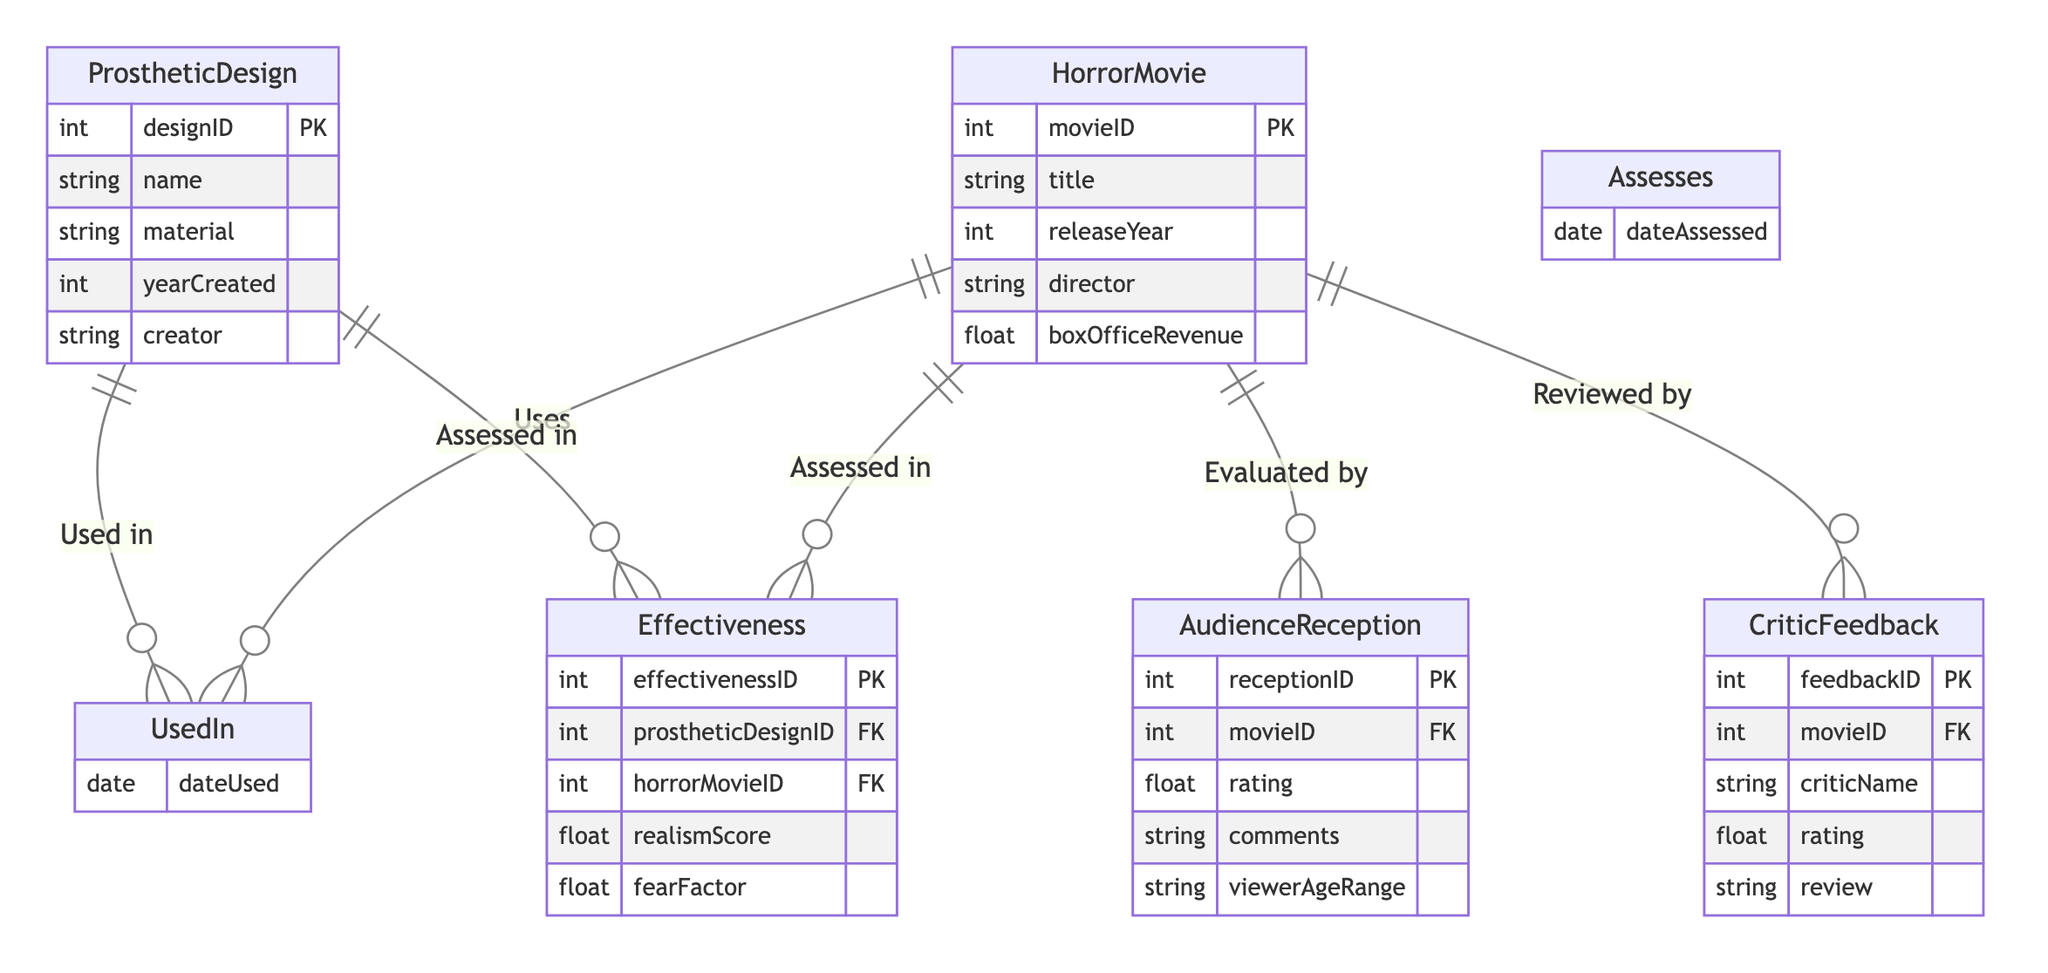What is the primary entity in the diagram? The diagram presents various entities, but the primary entity, reflecting the central theme of evaluating prosthetic designs in horror films, is "HorrorMovie."
Answer: HorrorMovie How many entities are represented in the diagram? The diagram contains a total of five distinct entities: ProstheticDesign, HorrorMovie, AudienceReception, CriticFeedback, and Effectiveness.
Answer: Five What relationship exists between ProstheticDesign and HorrorMovie? There is a relationship labeled "UsedIn," which indicates that a prosthetic design can be used in a horror movie, contributing to its visual effects.
Answer: UsedIn What attribute is present in CriticFeedback but not in AudienceReception? The CriticFeedback entity includes the attribute "criticName," which is not found in the AudienceReception entity.
Answer: criticName How is the Effectiveness of a prosthetic design assessed? The effectiveness is assessed based on two entities: "ProstheticDesign" and "HorrorMovie", in addition to the effectivenessScore and fearFactor attributes, which evaluate the realism of the design within the movie context.
Answer: Assessed in Which entity has a "rating" attribute? The entities "AudienceReception" and "CriticFeedback" both feature the "rating" attribute, indicating audience and critic evaluations respectively.
Answer: AudienceReception, CriticFeedback What is a unique attribute of the ProstheticDesign entity? The "ProstheticDesign" entity uniquely includes the attribute "yearCreated," which specifies when the design was made.
Answer: yearCreated Which entity allows for comments from viewers? The "AudienceReception" entity is designed to capture viewer feedback, which includes comments along with ratings provided by the audience.
Answer: AudienceReception What does the "Assesses" relationship indicate about the Effectiveness? The "Assesses" relationship signifies that the effectiveness of prosthetic designs is evaluated in relation to specific horror movies while including a timestamp for the assessment date.
Answer: Assesses 